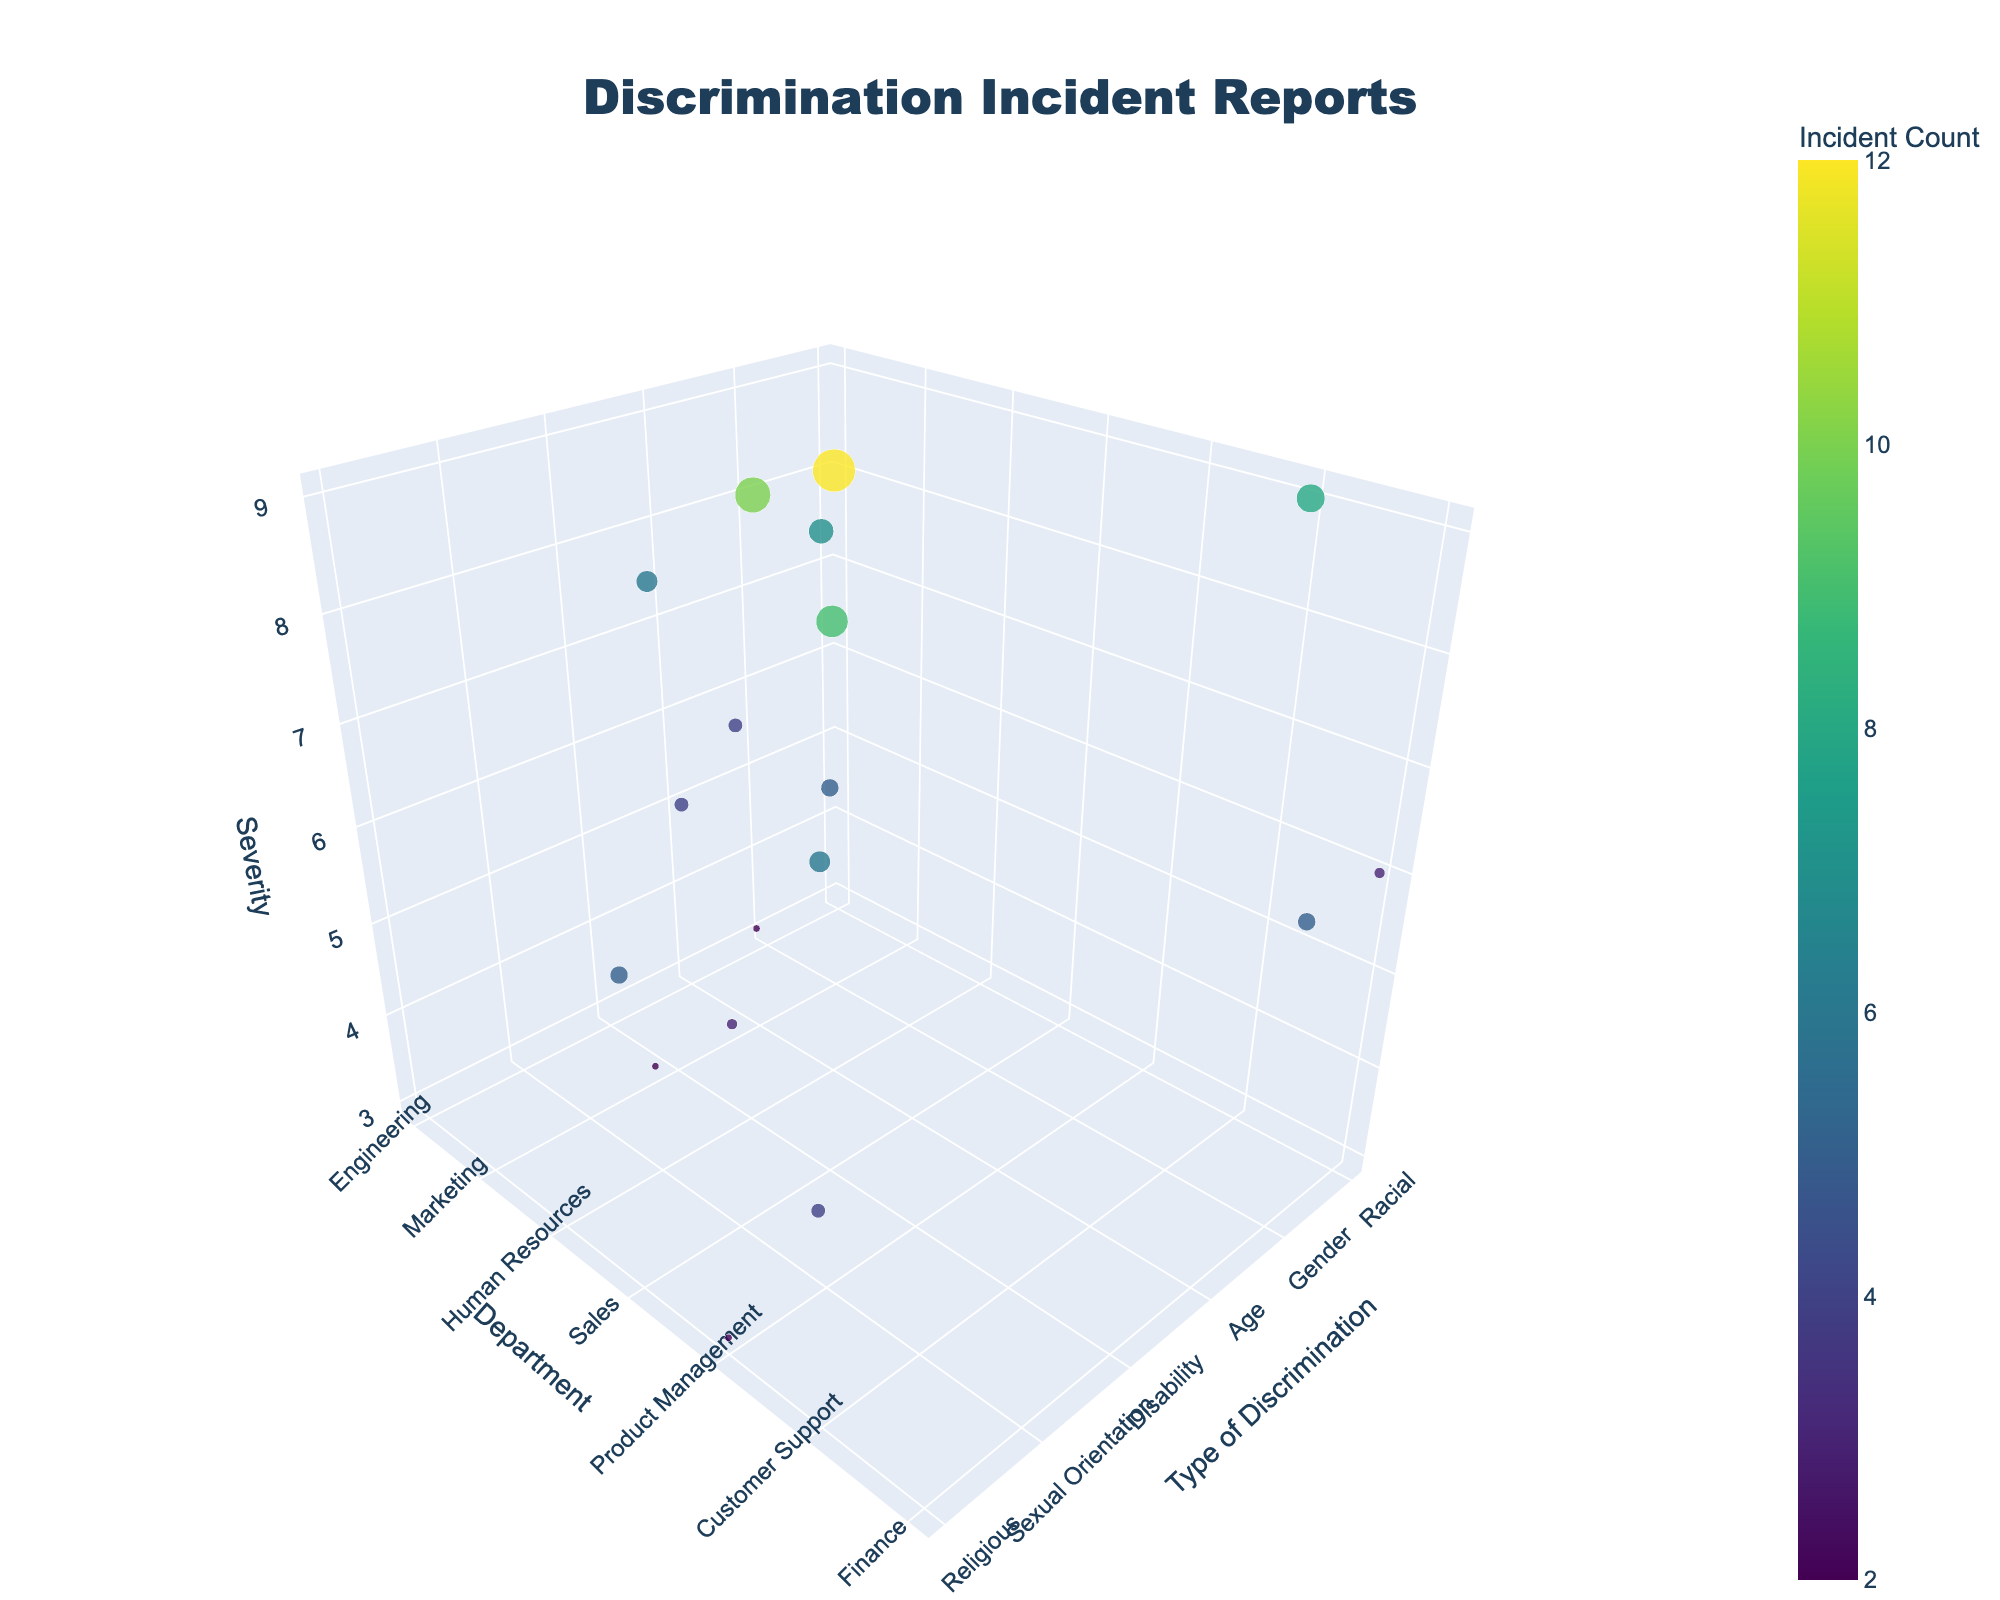What is the title of the figure? The title is usually displayed at the top of the figure. In this case, it is clearly stated in a large font as "Discrimination Incident Reports".
Answer: Discrimination Incident Reports Which department reported the highest severity of racial discrimination incidents? To find this, locate the 'Racial' points on the x-axis and check which 'Department' has the highest value on the z-axis (Severity). The 'Customer Support' department has the highest severity of 9.
Answer: Customer Support How many different types of discrimination incidents are represented in the plot? The types can be found on the x-axis of the plot. There are six types: Racial, Gender, Age, Disability, Sexual Orientation, and Religious. Counting these gives us the total number.
Answer: 6 Which department has the least number of incidents involving Disability discrimination? Identify the 'Disability' points on the x-axis and then find the smallest value in the 'Count' displayed in the hover info. The 'Human Resources' department has the least number of incidents with a count of 4.
Answer: Human Resources What is the average severity of Gender discrimination incidents reported? Locate all points corresponding to 'Gender' on the x-axis and note their z-axis (Severity) values: 7, 8, and 6. Calculate the average: (7 + 8 + 6) / 3 = 21 / 3.
Answer: 7 Which department has the highest number of discrimination incidents overall? Summarize the 'Count' values for each department across all types of discrimination. The 'Engineering' department has counts of 12 (Racial), 10 (Gender), and 4 (Age), totaling 26, which is the highest.
Answer: Engineering Between 'Engineering' and 'Sales', which department reports a higher average severity of discrimination incidents? Calculate the average severity for both departments:
- Engineering: (8 + 4 + 6) / 3 = 18 / 3 = 6
- Sales: (9 + 5) / 2 = 14 / 2 = 7
'Sales' has a higher average severity.
Answer: Sales Which type of discrimination has incidents reported in the most departments? Count the number of unique departments per each type of discrimination. 'Racial' and 'Gender' both have incidents reported in multiple departments. However, 'Gender' is reported in five departments (Marketing, Engineering, Finance).
Answer: Gender 